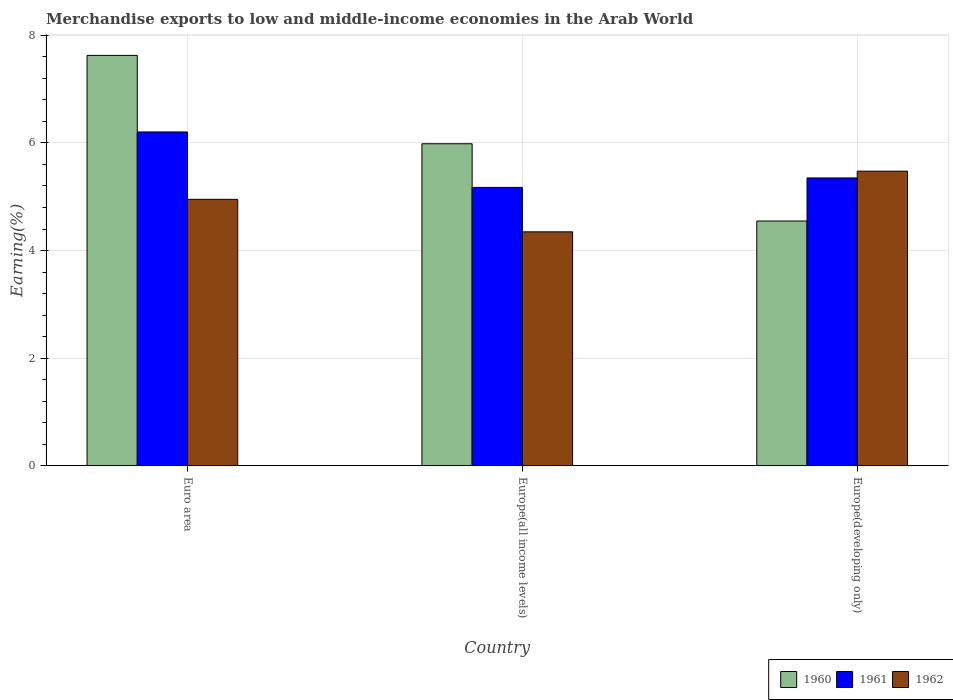How many different coloured bars are there?
Your answer should be very brief. 3. How many groups of bars are there?
Give a very brief answer. 3. Are the number of bars per tick equal to the number of legend labels?
Your answer should be very brief. Yes. Are the number of bars on each tick of the X-axis equal?
Give a very brief answer. Yes. How many bars are there on the 1st tick from the left?
Offer a very short reply. 3. What is the label of the 1st group of bars from the left?
Give a very brief answer. Euro area. In how many cases, is the number of bars for a given country not equal to the number of legend labels?
Your answer should be compact. 0. What is the percentage of amount earned from merchandise exports in 1961 in Europe(all income levels)?
Your answer should be very brief. 5.17. Across all countries, what is the maximum percentage of amount earned from merchandise exports in 1960?
Offer a terse response. 7.63. Across all countries, what is the minimum percentage of amount earned from merchandise exports in 1960?
Your answer should be very brief. 4.55. In which country was the percentage of amount earned from merchandise exports in 1962 maximum?
Provide a short and direct response. Europe(developing only). In which country was the percentage of amount earned from merchandise exports in 1960 minimum?
Give a very brief answer. Europe(developing only). What is the total percentage of amount earned from merchandise exports in 1961 in the graph?
Make the answer very short. 16.73. What is the difference between the percentage of amount earned from merchandise exports in 1961 in Europe(all income levels) and that in Europe(developing only)?
Your answer should be very brief. -0.18. What is the difference between the percentage of amount earned from merchandise exports in 1962 in Europe(all income levels) and the percentage of amount earned from merchandise exports in 1960 in Euro area?
Provide a short and direct response. -3.28. What is the average percentage of amount earned from merchandise exports in 1962 per country?
Your response must be concise. 4.92. What is the difference between the percentage of amount earned from merchandise exports of/in 1960 and percentage of amount earned from merchandise exports of/in 1961 in Europe(developing only)?
Your answer should be very brief. -0.8. What is the ratio of the percentage of amount earned from merchandise exports in 1962 in Europe(all income levels) to that in Europe(developing only)?
Keep it short and to the point. 0.79. Is the difference between the percentage of amount earned from merchandise exports in 1960 in Euro area and Europe(developing only) greater than the difference between the percentage of amount earned from merchandise exports in 1961 in Euro area and Europe(developing only)?
Give a very brief answer. Yes. What is the difference between the highest and the second highest percentage of amount earned from merchandise exports in 1960?
Provide a short and direct response. -1.44. What is the difference between the highest and the lowest percentage of amount earned from merchandise exports in 1960?
Make the answer very short. 3.08. What does the 1st bar from the left in Europe(developing only) represents?
Ensure brevity in your answer.  1960. What does the 3rd bar from the right in Europe(all income levels) represents?
Offer a very short reply. 1960. Is it the case that in every country, the sum of the percentage of amount earned from merchandise exports in 1961 and percentage of amount earned from merchandise exports in 1960 is greater than the percentage of amount earned from merchandise exports in 1962?
Ensure brevity in your answer.  Yes. How many bars are there?
Ensure brevity in your answer.  9. What is the difference between two consecutive major ticks on the Y-axis?
Make the answer very short. 2. Does the graph contain any zero values?
Your answer should be very brief. No. Does the graph contain grids?
Your answer should be compact. Yes. How many legend labels are there?
Provide a succinct answer. 3. How are the legend labels stacked?
Provide a short and direct response. Horizontal. What is the title of the graph?
Give a very brief answer. Merchandise exports to low and middle-income economies in the Arab World. Does "1975" appear as one of the legend labels in the graph?
Provide a succinct answer. No. What is the label or title of the Y-axis?
Offer a very short reply. Earning(%). What is the Earning(%) in 1960 in Euro area?
Ensure brevity in your answer.  7.63. What is the Earning(%) in 1961 in Euro area?
Offer a terse response. 6.2. What is the Earning(%) of 1962 in Euro area?
Offer a very short reply. 4.95. What is the Earning(%) in 1960 in Europe(all income levels)?
Your answer should be compact. 5.98. What is the Earning(%) in 1961 in Europe(all income levels)?
Provide a succinct answer. 5.17. What is the Earning(%) of 1962 in Europe(all income levels)?
Provide a succinct answer. 4.35. What is the Earning(%) in 1960 in Europe(developing only)?
Your answer should be compact. 4.55. What is the Earning(%) of 1961 in Europe(developing only)?
Keep it short and to the point. 5.35. What is the Earning(%) in 1962 in Europe(developing only)?
Give a very brief answer. 5.48. Across all countries, what is the maximum Earning(%) in 1960?
Provide a succinct answer. 7.63. Across all countries, what is the maximum Earning(%) in 1961?
Your answer should be very brief. 6.2. Across all countries, what is the maximum Earning(%) in 1962?
Your answer should be compact. 5.48. Across all countries, what is the minimum Earning(%) in 1960?
Your response must be concise. 4.55. Across all countries, what is the minimum Earning(%) of 1961?
Keep it short and to the point. 5.17. Across all countries, what is the minimum Earning(%) in 1962?
Keep it short and to the point. 4.35. What is the total Earning(%) of 1960 in the graph?
Offer a very short reply. 18.16. What is the total Earning(%) in 1961 in the graph?
Provide a succinct answer. 16.73. What is the total Earning(%) in 1962 in the graph?
Keep it short and to the point. 14.77. What is the difference between the Earning(%) in 1960 in Euro area and that in Europe(all income levels)?
Ensure brevity in your answer.  1.64. What is the difference between the Earning(%) in 1961 in Euro area and that in Europe(all income levels)?
Give a very brief answer. 1.03. What is the difference between the Earning(%) in 1962 in Euro area and that in Europe(all income levels)?
Offer a very short reply. 0.6. What is the difference between the Earning(%) in 1960 in Euro area and that in Europe(developing only)?
Your answer should be very brief. 3.08. What is the difference between the Earning(%) of 1961 in Euro area and that in Europe(developing only)?
Offer a very short reply. 0.85. What is the difference between the Earning(%) of 1962 in Euro area and that in Europe(developing only)?
Make the answer very short. -0.52. What is the difference between the Earning(%) in 1960 in Europe(all income levels) and that in Europe(developing only)?
Give a very brief answer. 1.44. What is the difference between the Earning(%) in 1961 in Europe(all income levels) and that in Europe(developing only)?
Provide a succinct answer. -0.18. What is the difference between the Earning(%) in 1962 in Europe(all income levels) and that in Europe(developing only)?
Offer a very short reply. -1.13. What is the difference between the Earning(%) of 1960 in Euro area and the Earning(%) of 1961 in Europe(all income levels)?
Keep it short and to the point. 2.45. What is the difference between the Earning(%) in 1960 in Euro area and the Earning(%) in 1962 in Europe(all income levels)?
Offer a terse response. 3.28. What is the difference between the Earning(%) in 1961 in Euro area and the Earning(%) in 1962 in Europe(all income levels)?
Provide a succinct answer. 1.86. What is the difference between the Earning(%) in 1960 in Euro area and the Earning(%) in 1961 in Europe(developing only)?
Make the answer very short. 2.28. What is the difference between the Earning(%) in 1960 in Euro area and the Earning(%) in 1962 in Europe(developing only)?
Provide a succinct answer. 2.15. What is the difference between the Earning(%) in 1961 in Euro area and the Earning(%) in 1962 in Europe(developing only)?
Provide a short and direct response. 0.73. What is the difference between the Earning(%) of 1960 in Europe(all income levels) and the Earning(%) of 1961 in Europe(developing only)?
Give a very brief answer. 0.64. What is the difference between the Earning(%) in 1960 in Europe(all income levels) and the Earning(%) in 1962 in Europe(developing only)?
Make the answer very short. 0.51. What is the difference between the Earning(%) of 1961 in Europe(all income levels) and the Earning(%) of 1962 in Europe(developing only)?
Provide a succinct answer. -0.3. What is the average Earning(%) of 1960 per country?
Ensure brevity in your answer.  6.05. What is the average Earning(%) of 1961 per country?
Ensure brevity in your answer.  5.58. What is the average Earning(%) in 1962 per country?
Offer a very short reply. 4.92. What is the difference between the Earning(%) of 1960 and Earning(%) of 1961 in Euro area?
Your answer should be compact. 1.42. What is the difference between the Earning(%) in 1960 and Earning(%) in 1962 in Euro area?
Ensure brevity in your answer.  2.68. What is the difference between the Earning(%) in 1961 and Earning(%) in 1962 in Euro area?
Your answer should be very brief. 1.25. What is the difference between the Earning(%) of 1960 and Earning(%) of 1961 in Europe(all income levels)?
Provide a succinct answer. 0.81. What is the difference between the Earning(%) in 1960 and Earning(%) in 1962 in Europe(all income levels)?
Offer a terse response. 1.64. What is the difference between the Earning(%) of 1961 and Earning(%) of 1962 in Europe(all income levels)?
Give a very brief answer. 0.83. What is the difference between the Earning(%) of 1960 and Earning(%) of 1961 in Europe(developing only)?
Keep it short and to the point. -0.8. What is the difference between the Earning(%) in 1960 and Earning(%) in 1962 in Europe(developing only)?
Make the answer very short. -0.93. What is the difference between the Earning(%) in 1961 and Earning(%) in 1962 in Europe(developing only)?
Offer a very short reply. -0.13. What is the ratio of the Earning(%) in 1960 in Euro area to that in Europe(all income levels)?
Your answer should be very brief. 1.27. What is the ratio of the Earning(%) in 1961 in Euro area to that in Europe(all income levels)?
Give a very brief answer. 1.2. What is the ratio of the Earning(%) in 1962 in Euro area to that in Europe(all income levels)?
Make the answer very short. 1.14. What is the ratio of the Earning(%) of 1960 in Euro area to that in Europe(developing only)?
Provide a succinct answer. 1.68. What is the ratio of the Earning(%) in 1961 in Euro area to that in Europe(developing only)?
Your answer should be compact. 1.16. What is the ratio of the Earning(%) in 1962 in Euro area to that in Europe(developing only)?
Give a very brief answer. 0.9. What is the ratio of the Earning(%) in 1960 in Europe(all income levels) to that in Europe(developing only)?
Your response must be concise. 1.32. What is the ratio of the Earning(%) in 1961 in Europe(all income levels) to that in Europe(developing only)?
Offer a terse response. 0.97. What is the ratio of the Earning(%) in 1962 in Europe(all income levels) to that in Europe(developing only)?
Offer a terse response. 0.79. What is the difference between the highest and the second highest Earning(%) in 1960?
Your answer should be compact. 1.64. What is the difference between the highest and the second highest Earning(%) in 1961?
Offer a very short reply. 0.85. What is the difference between the highest and the second highest Earning(%) in 1962?
Provide a short and direct response. 0.52. What is the difference between the highest and the lowest Earning(%) in 1960?
Keep it short and to the point. 3.08. What is the difference between the highest and the lowest Earning(%) of 1961?
Provide a short and direct response. 1.03. What is the difference between the highest and the lowest Earning(%) of 1962?
Keep it short and to the point. 1.13. 